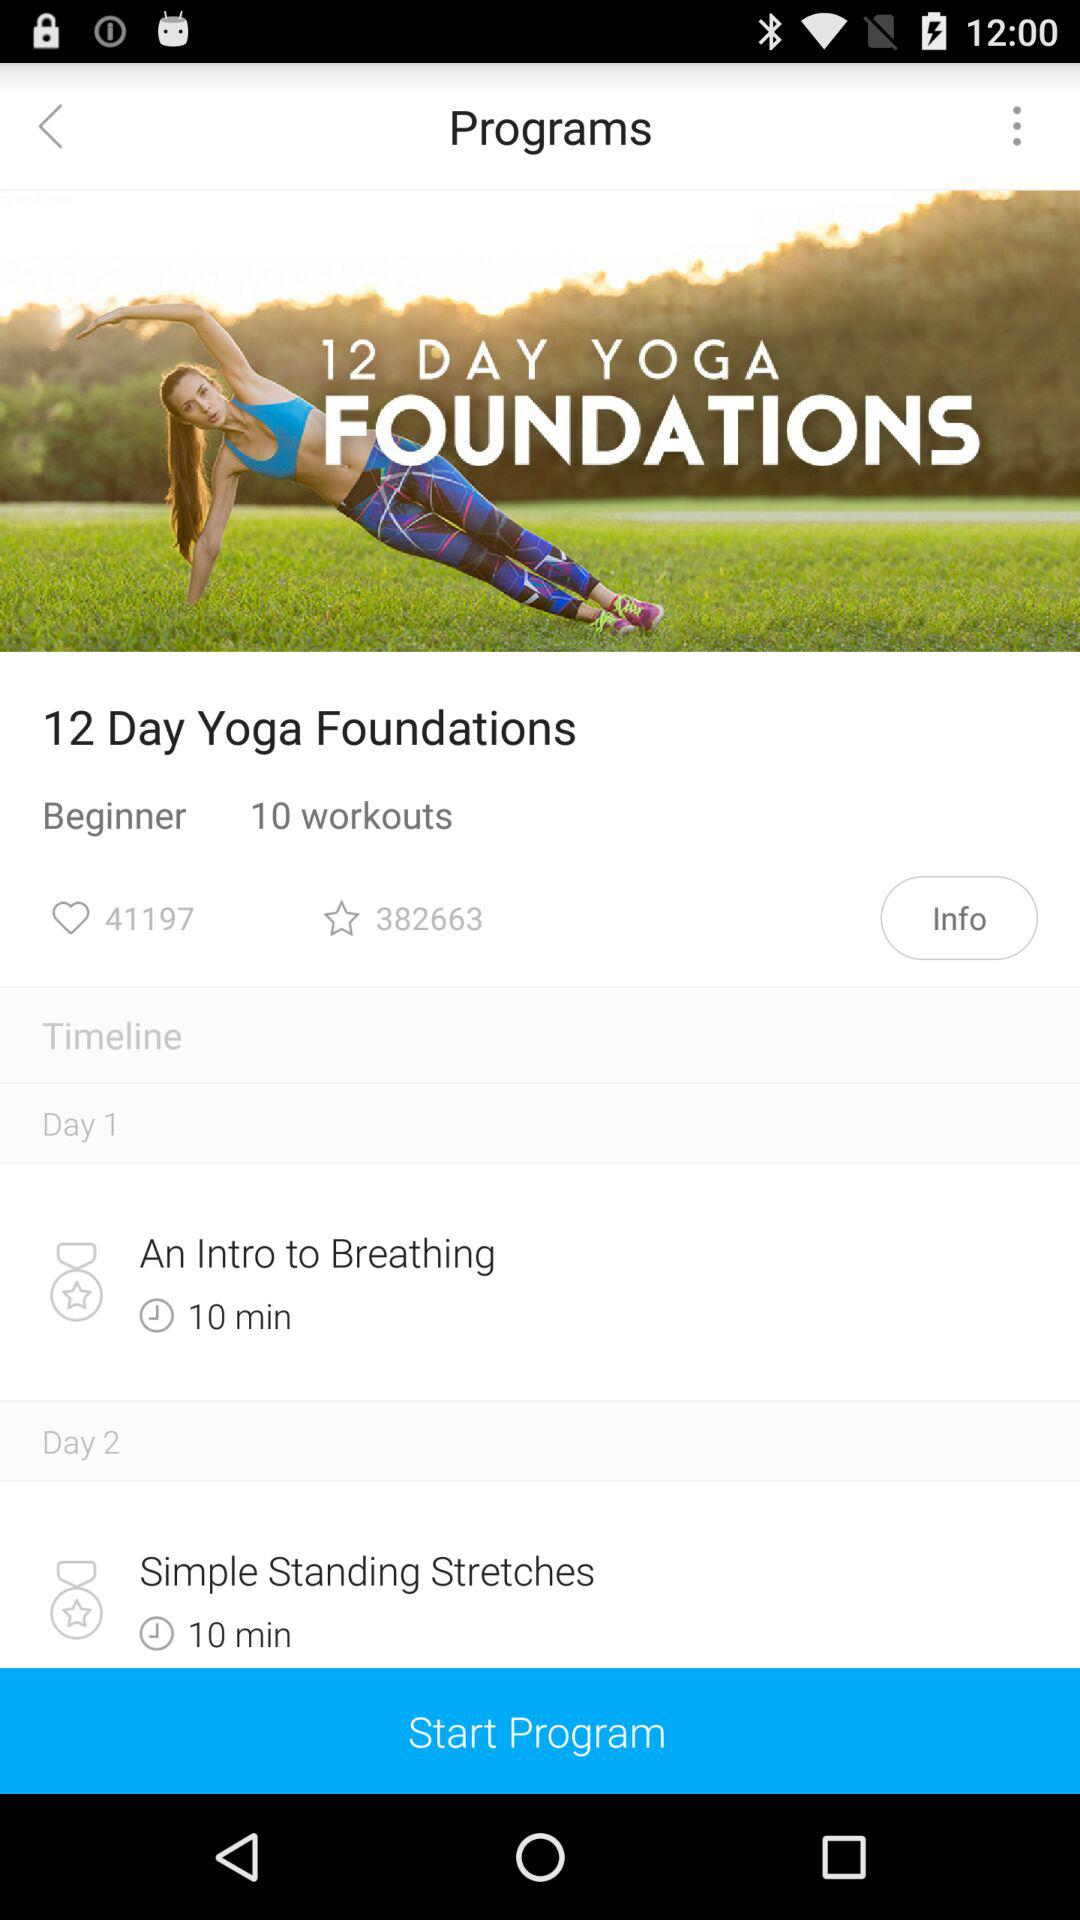What is the schedule for Day 2? The schedule for Day 2 is "Simple Standing Stretches". 